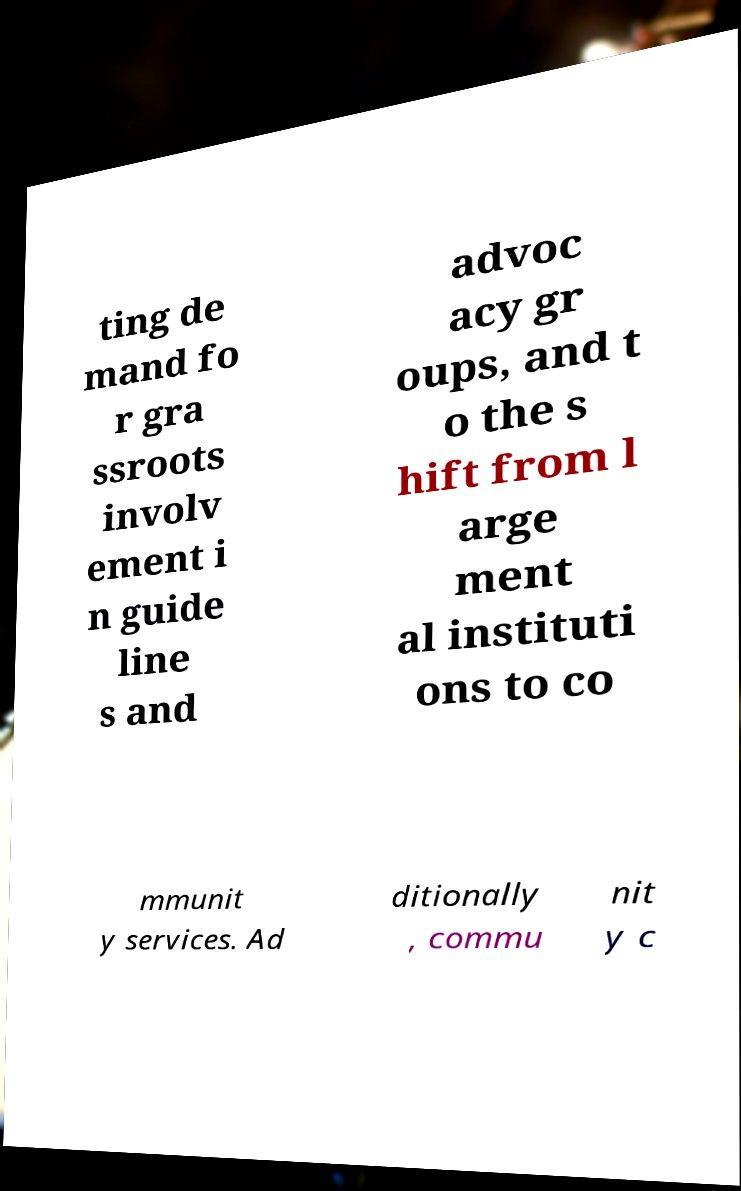Can you read and provide the text displayed in the image?This photo seems to have some interesting text. Can you extract and type it out for me? ting de mand fo r gra ssroots involv ement i n guide line s and advoc acy gr oups, and t o the s hift from l arge ment al instituti ons to co mmunit y services. Ad ditionally , commu nit y c 